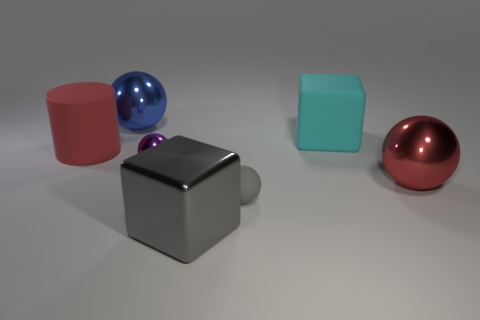Subtract 1 spheres. How many spheres are left? 3 Add 1 cyan blocks. How many objects exist? 8 Subtract all cyan spheres. Subtract all green cylinders. How many spheres are left? 4 Subtract all spheres. How many objects are left? 3 Add 1 shiny blocks. How many shiny blocks are left? 2 Add 6 green cylinders. How many green cylinders exist? 6 Subtract 1 gray balls. How many objects are left? 6 Subtract all red matte cylinders. Subtract all red cylinders. How many objects are left? 5 